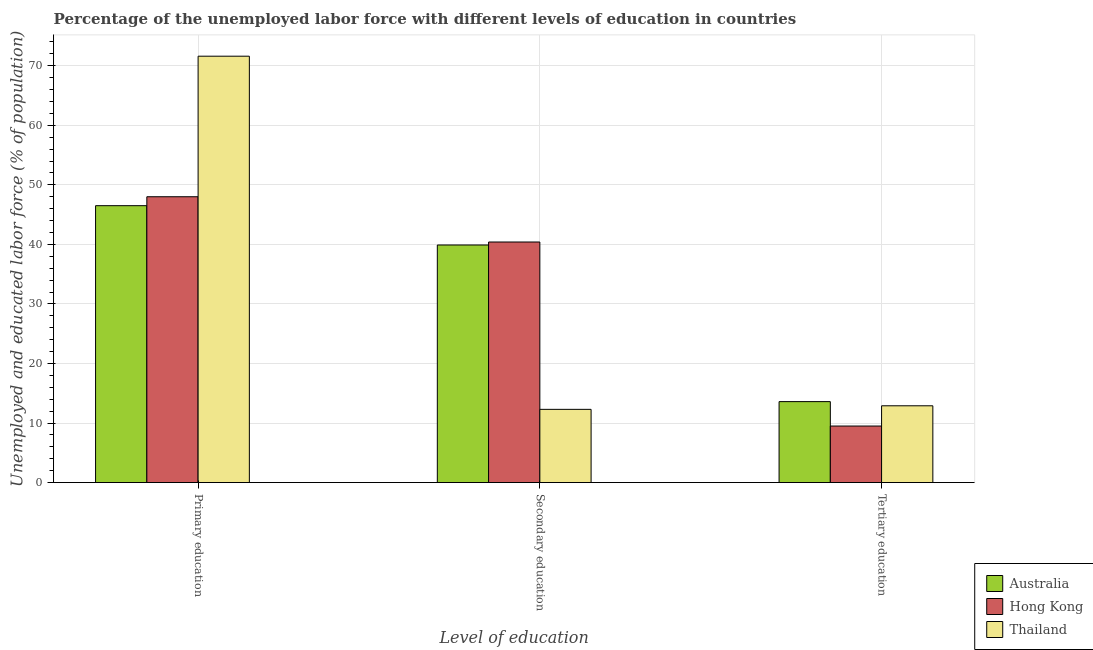How many different coloured bars are there?
Keep it short and to the point. 3. How many bars are there on the 3rd tick from the right?
Your answer should be compact. 3. What is the label of the 3rd group of bars from the left?
Ensure brevity in your answer.  Tertiary education. What is the percentage of labor force who received tertiary education in Thailand?
Provide a short and direct response. 12.9. Across all countries, what is the maximum percentage of labor force who received primary education?
Offer a terse response. 71.6. Across all countries, what is the minimum percentage of labor force who received primary education?
Give a very brief answer. 46.5. In which country was the percentage of labor force who received primary education maximum?
Ensure brevity in your answer.  Thailand. What is the total percentage of labor force who received secondary education in the graph?
Your response must be concise. 92.6. What is the difference between the percentage of labor force who received tertiary education in Australia and that in Hong Kong?
Offer a very short reply. 4.1. What is the difference between the percentage of labor force who received secondary education in Thailand and the percentage of labor force who received primary education in Hong Kong?
Provide a short and direct response. -35.7. What is the average percentage of labor force who received secondary education per country?
Offer a very short reply. 30.87. What is the difference between the percentage of labor force who received primary education and percentage of labor force who received secondary education in Hong Kong?
Give a very brief answer. 7.6. What is the ratio of the percentage of labor force who received tertiary education in Hong Kong to that in Thailand?
Keep it short and to the point. 0.74. Is the percentage of labor force who received primary education in Hong Kong less than that in Australia?
Your response must be concise. No. What is the difference between the highest and the second highest percentage of labor force who received primary education?
Your answer should be very brief. 23.6. What is the difference between the highest and the lowest percentage of labor force who received primary education?
Provide a succinct answer. 25.1. In how many countries, is the percentage of labor force who received primary education greater than the average percentage of labor force who received primary education taken over all countries?
Offer a very short reply. 1. Is the sum of the percentage of labor force who received secondary education in Hong Kong and Thailand greater than the maximum percentage of labor force who received primary education across all countries?
Provide a succinct answer. No. What does the 2nd bar from the right in Tertiary education represents?
Offer a terse response. Hong Kong. How many countries are there in the graph?
Provide a short and direct response. 3. Are the values on the major ticks of Y-axis written in scientific E-notation?
Give a very brief answer. No. Does the graph contain grids?
Provide a succinct answer. Yes. Where does the legend appear in the graph?
Keep it short and to the point. Bottom right. How are the legend labels stacked?
Offer a very short reply. Vertical. What is the title of the graph?
Offer a very short reply. Percentage of the unemployed labor force with different levels of education in countries. What is the label or title of the X-axis?
Keep it short and to the point. Level of education. What is the label or title of the Y-axis?
Provide a succinct answer. Unemployed and educated labor force (% of population). What is the Unemployed and educated labor force (% of population) in Australia in Primary education?
Give a very brief answer. 46.5. What is the Unemployed and educated labor force (% of population) in Thailand in Primary education?
Make the answer very short. 71.6. What is the Unemployed and educated labor force (% of population) of Australia in Secondary education?
Offer a very short reply. 39.9. What is the Unemployed and educated labor force (% of population) of Hong Kong in Secondary education?
Keep it short and to the point. 40.4. What is the Unemployed and educated labor force (% of population) of Thailand in Secondary education?
Your response must be concise. 12.3. What is the Unemployed and educated labor force (% of population) of Australia in Tertiary education?
Your answer should be very brief. 13.6. What is the Unemployed and educated labor force (% of population) of Thailand in Tertiary education?
Your response must be concise. 12.9. Across all Level of education, what is the maximum Unemployed and educated labor force (% of population) in Australia?
Keep it short and to the point. 46.5. Across all Level of education, what is the maximum Unemployed and educated labor force (% of population) in Thailand?
Give a very brief answer. 71.6. Across all Level of education, what is the minimum Unemployed and educated labor force (% of population) in Australia?
Provide a short and direct response. 13.6. Across all Level of education, what is the minimum Unemployed and educated labor force (% of population) in Thailand?
Make the answer very short. 12.3. What is the total Unemployed and educated labor force (% of population) of Australia in the graph?
Ensure brevity in your answer.  100. What is the total Unemployed and educated labor force (% of population) in Hong Kong in the graph?
Provide a succinct answer. 97.9. What is the total Unemployed and educated labor force (% of population) of Thailand in the graph?
Your answer should be very brief. 96.8. What is the difference between the Unemployed and educated labor force (% of population) of Australia in Primary education and that in Secondary education?
Make the answer very short. 6.6. What is the difference between the Unemployed and educated labor force (% of population) in Hong Kong in Primary education and that in Secondary education?
Make the answer very short. 7.6. What is the difference between the Unemployed and educated labor force (% of population) in Thailand in Primary education and that in Secondary education?
Offer a terse response. 59.3. What is the difference between the Unemployed and educated labor force (% of population) in Australia in Primary education and that in Tertiary education?
Your response must be concise. 32.9. What is the difference between the Unemployed and educated labor force (% of population) of Hong Kong in Primary education and that in Tertiary education?
Give a very brief answer. 38.5. What is the difference between the Unemployed and educated labor force (% of population) of Thailand in Primary education and that in Tertiary education?
Ensure brevity in your answer.  58.7. What is the difference between the Unemployed and educated labor force (% of population) in Australia in Secondary education and that in Tertiary education?
Make the answer very short. 26.3. What is the difference between the Unemployed and educated labor force (% of population) in Hong Kong in Secondary education and that in Tertiary education?
Keep it short and to the point. 30.9. What is the difference between the Unemployed and educated labor force (% of population) in Australia in Primary education and the Unemployed and educated labor force (% of population) in Hong Kong in Secondary education?
Your response must be concise. 6.1. What is the difference between the Unemployed and educated labor force (% of population) in Australia in Primary education and the Unemployed and educated labor force (% of population) in Thailand in Secondary education?
Offer a terse response. 34.2. What is the difference between the Unemployed and educated labor force (% of population) of Hong Kong in Primary education and the Unemployed and educated labor force (% of population) of Thailand in Secondary education?
Your answer should be very brief. 35.7. What is the difference between the Unemployed and educated labor force (% of population) in Australia in Primary education and the Unemployed and educated labor force (% of population) in Thailand in Tertiary education?
Keep it short and to the point. 33.6. What is the difference between the Unemployed and educated labor force (% of population) in Hong Kong in Primary education and the Unemployed and educated labor force (% of population) in Thailand in Tertiary education?
Provide a succinct answer. 35.1. What is the difference between the Unemployed and educated labor force (% of population) in Australia in Secondary education and the Unemployed and educated labor force (% of population) in Hong Kong in Tertiary education?
Your answer should be compact. 30.4. What is the difference between the Unemployed and educated labor force (% of population) in Australia in Secondary education and the Unemployed and educated labor force (% of population) in Thailand in Tertiary education?
Offer a terse response. 27. What is the average Unemployed and educated labor force (% of population) in Australia per Level of education?
Give a very brief answer. 33.33. What is the average Unemployed and educated labor force (% of population) in Hong Kong per Level of education?
Ensure brevity in your answer.  32.63. What is the average Unemployed and educated labor force (% of population) in Thailand per Level of education?
Keep it short and to the point. 32.27. What is the difference between the Unemployed and educated labor force (% of population) in Australia and Unemployed and educated labor force (% of population) in Thailand in Primary education?
Give a very brief answer. -25.1. What is the difference between the Unemployed and educated labor force (% of population) of Hong Kong and Unemployed and educated labor force (% of population) of Thailand in Primary education?
Provide a short and direct response. -23.6. What is the difference between the Unemployed and educated labor force (% of population) of Australia and Unemployed and educated labor force (% of population) of Thailand in Secondary education?
Keep it short and to the point. 27.6. What is the difference between the Unemployed and educated labor force (% of population) in Hong Kong and Unemployed and educated labor force (% of population) in Thailand in Secondary education?
Make the answer very short. 28.1. What is the difference between the Unemployed and educated labor force (% of population) of Hong Kong and Unemployed and educated labor force (% of population) of Thailand in Tertiary education?
Provide a succinct answer. -3.4. What is the ratio of the Unemployed and educated labor force (% of population) of Australia in Primary education to that in Secondary education?
Your answer should be very brief. 1.17. What is the ratio of the Unemployed and educated labor force (% of population) of Hong Kong in Primary education to that in Secondary education?
Make the answer very short. 1.19. What is the ratio of the Unemployed and educated labor force (% of population) of Thailand in Primary education to that in Secondary education?
Provide a succinct answer. 5.82. What is the ratio of the Unemployed and educated labor force (% of population) in Australia in Primary education to that in Tertiary education?
Your response must be concise. 3.42. What is the ratio of the Unemployed and educated labor force (% of population) in Hong Kong in Primary education to that in Tertiary education?
Ensure brevity in your answer.  5.05. What is the ratio of the Unemployed and educated labor force (% of population) in Thailand in Primary education to that in Tertiary education?
Your answer should be compact. 5.55. What is the ratio of the Unemployed and educated labor force (% of population) in Australia in Secondary education to that in Tertiary education?
Offer a very short reply. 2.93. What is the ratio of the Unemployed and educated labor force (% of population) in Hong Kong in Secondary education to that in Tertiary education?
Your answer should be compact. 4.25. What is the ratio of the Unemployed and educated labor force (% of population) in Thailand in Secondary education to that in Tertiary education?
Give a very brief answer. 0.95. What is the difference between the highest and the second highest Unemployed and educated labor force (% of population) in Australia?
Offer a terse response. 6.6. What is the difference between the highest and the second highest Unemployed and educated labor force (% of population) of Thailand?
Your answer should be very brief. 58.7. What is the difference between the highest and the lowest Unemployed and educated labor force (% of population) of Australia?
Your response must be concise. 32.9. What is the difference between the highest and the lowest Unemployed and educated labor force (% of population) in Hong Kong?
Offer a very short reply. 38.5. What is the difference between the highest and the lowest Unemployed and educated labor force (% of population) in Thailand?
Offer a terse response. 59.3. 